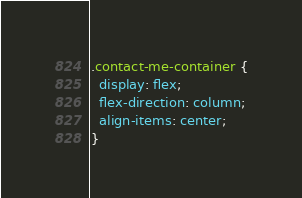<code> <loc_0><loc_0><loc_500><loc_500><_CSS_>.contact-me-container {
  display: flex;
  flex-direction: column;
  align-items: center;
}
</code> 